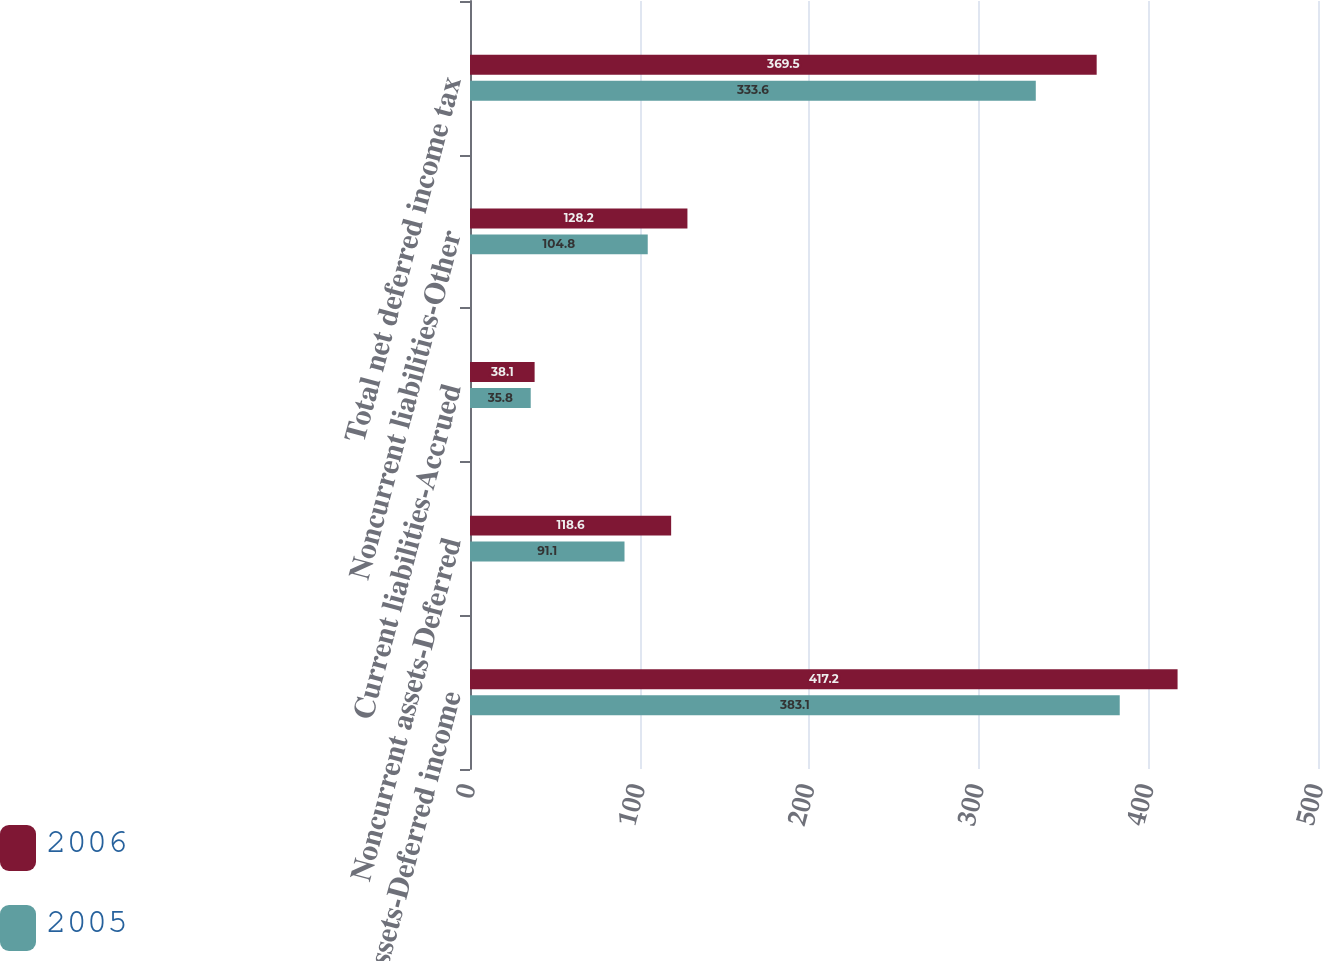Convert chart. <chart><loc_0><loc_0><loc_500><loc_500><stacked_bar_chart><ecel><fcel>Current assets-Deferred income<fcel>Noncurrent assets-Deferred<fcel>Current liabilities-Accrued<fcel>Noncurrent liabilities-Other<fcel>Total net deferred income tax<nl><fcel>2006<fcel>417.2<fcel>118.6<fcel>38.1<fcel>128.2<fcel>369.5<nl><fcel>2005<fcel>383.1<fcel>91.1<fcel>35.8<fcel>104.8<fcel>333.6<nl></chart> 